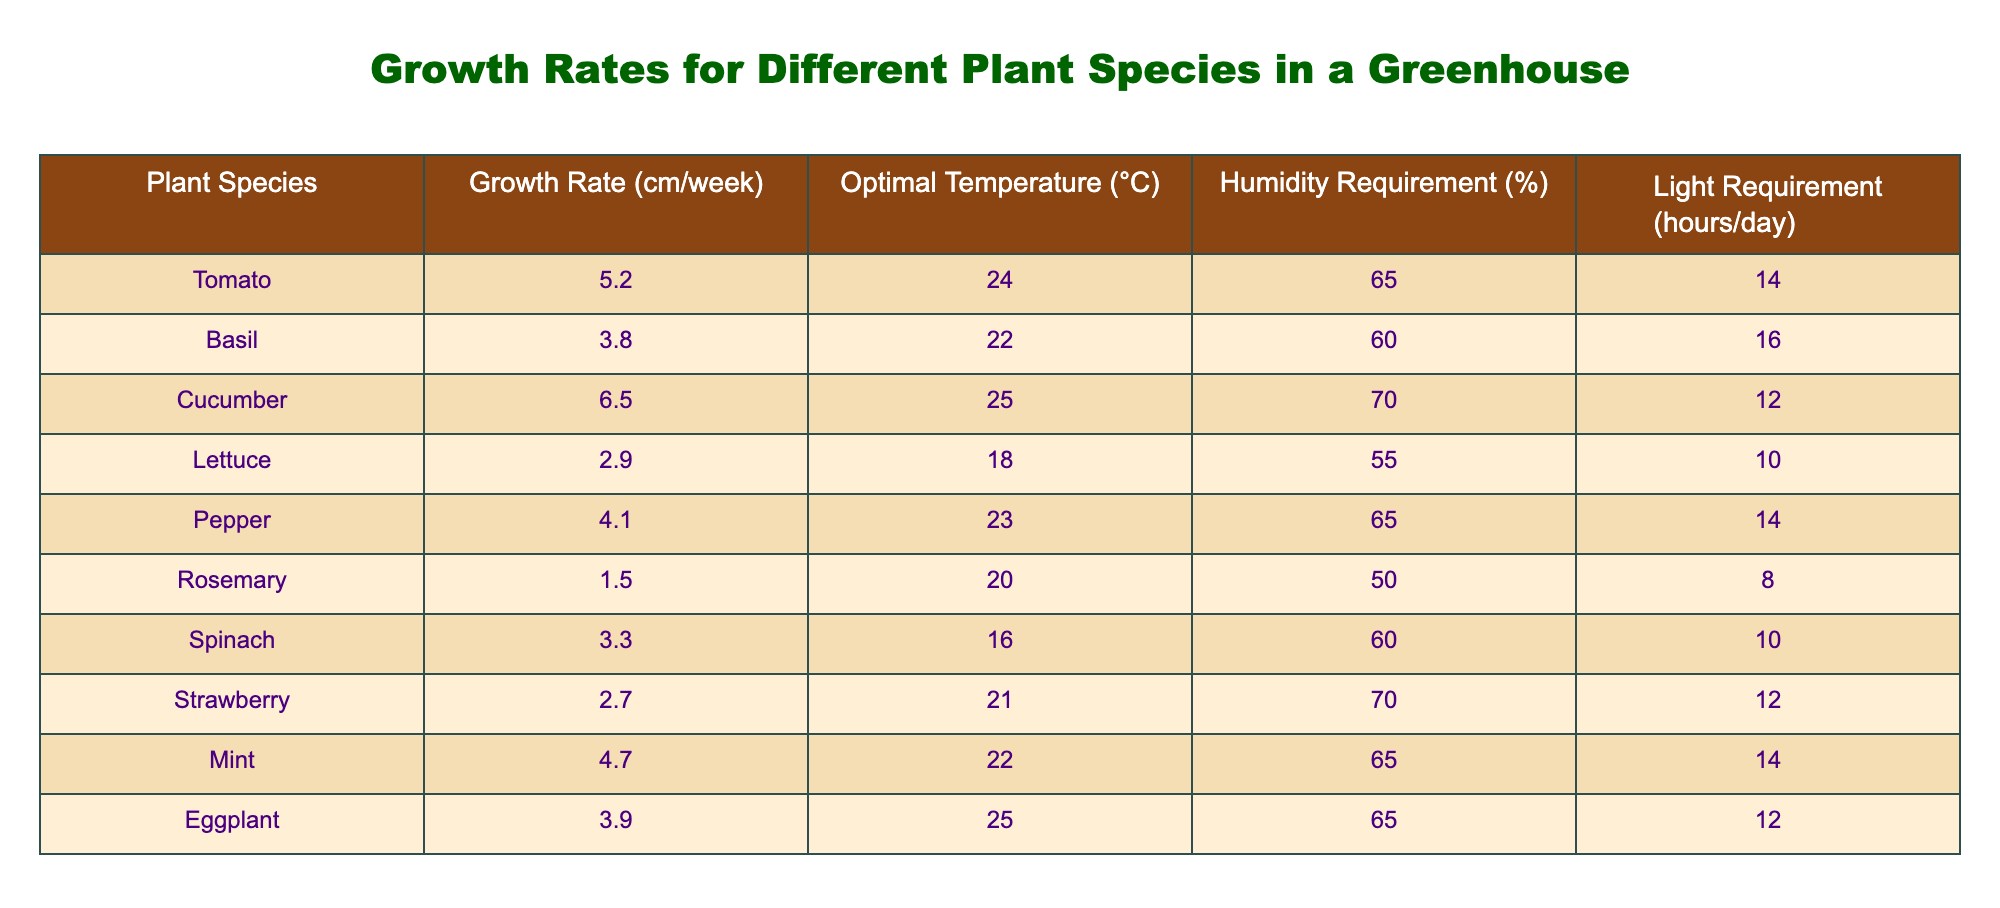What is the growth rate of Cucumber? The table shows that the growth rate for Cucumber is listed specifically under the "Growth Rate (cm/week)" column next to the Cucumber row, which is 6.5 cm/week.
Answer: 6.5 Which plant species has the lowest growth rate? By scanning the "Growth Rate (cm/week)" column, we can identify that Rosemary has the lowest value, which is 1.5 cm/week.
Answer: Rosemary What is the optimal temperature for growing Basil? The optimal temperature for Basil is found in the "Optimal Temperature (°C)" column next to the Basil row, which indicates a temperature of 22°C is optimal.
Answer: 22°C Is it true that Pepper requires less than 70% humidity? Looking at the "Humidity Requirement (%)" column, we see that Pepper has a humidity requirement of 65%, which confirms that it is indeed less than 70%.
Answer: Yes What is the average growth rate of all the plants listed? To find the average growth rate, we first sum the growth rates of all species (5.2 + 3.8 + 6.5 + 2.9 + 4.1 + 1.5 + 3.3 + 2.7 + 4.7 + 3.9 = 34.6) and then divide by the number of species (10). Thus, the average growth rate is 34.6/10 = 3.46 cm/week.
Answer: 3.46 cm/week Which plant requires the most light hours per day and what is that requirement? The "Light Requirement (hours/day)" column must be examined for the maximum value. The maximum, 16 hours/day, corresponds to Basil, making it the plant with the highest light requirement.
Answer: 16 hours/day (Basil) Are all of the plant species in the table suitable for temperatures above 20°C? By reviewing the "Optimal Temperature (°C)" column, we see that only Basil (22°C), Cucumber (25°C), Pepper (23°C), and Eggplant (25°C) are above 20°C. Lettuce (18°C) and Rosemary (20°C) do not meet this criterion. Thus, it is false that all species are suitable for above 20°C.
Answer: No How many plant species require a humidity level of 65%? By checking the "Humidity Requirement (%)" column, we find three plants – Tomato, Pepper, and Mint – which require 65% humidity.
Answer: 3 